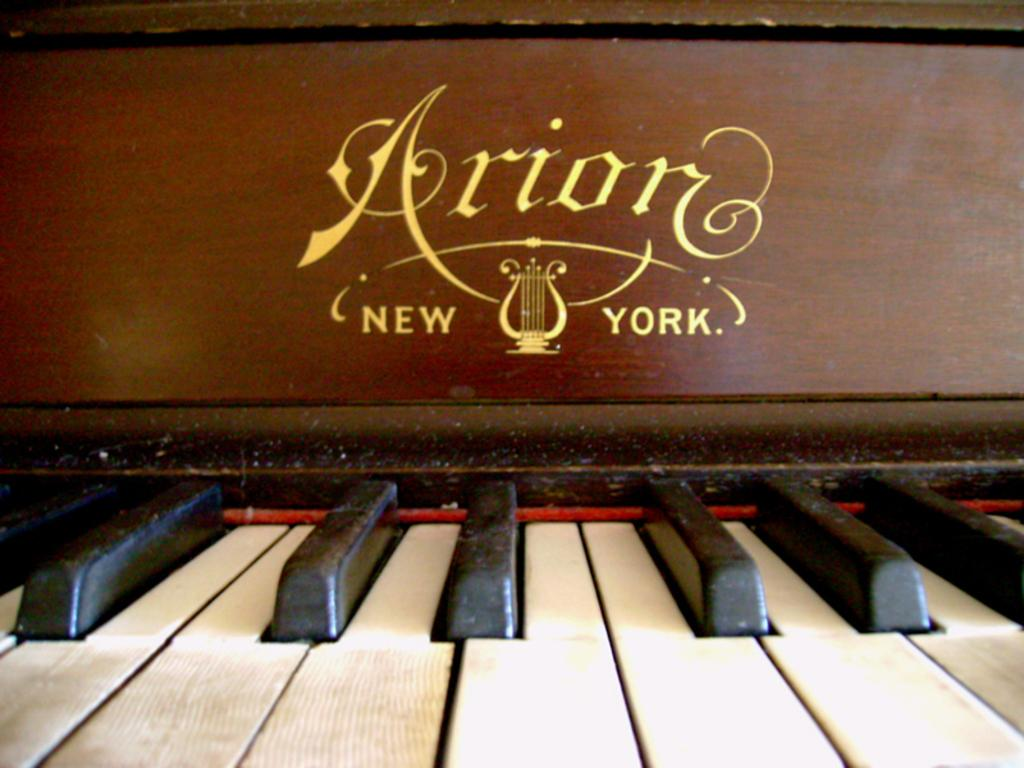What is the main object in the image? There is a piano in the image. How many maids are attending to the piano in the image? There is no mention of maids or any other people in the image; it only features a piano. What time of day is it in the image? The provided facts do not mention the time of day or any hour-related information. 